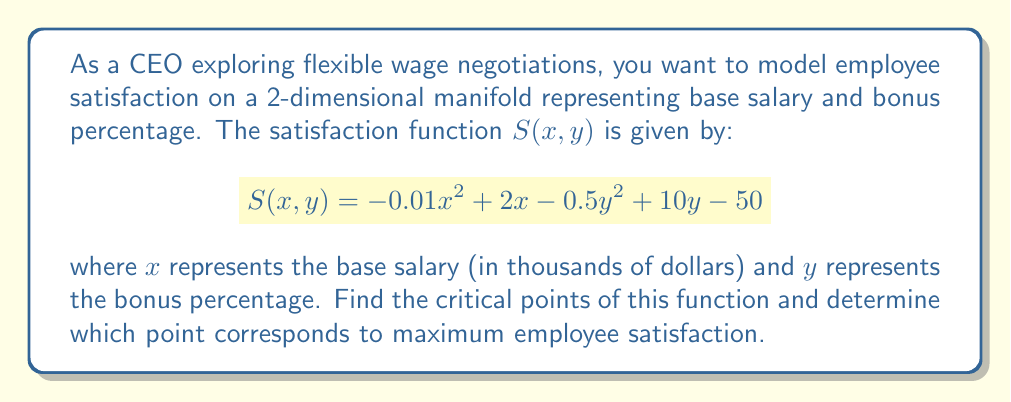Solve this math problem. To find the critical points of the satisfaction function $S(x,y)$, we need to follow these steps:

1. Calculate the partial derivatives of $S$ with respect to $x$ and $y$:

   $$\frac{\partial S}{\partial x} = -0.02x + 2$$
   $$\frac{\partial S}{\partial y} = -y + 10$$

2. Set both partial derivatives to zero and solve the resulting system of equations:

   $$-0.02x + 2 = 0$$
   $$-y + 10 = 0$$

3. Solve for $x$ and $y$:

   $$x = \frac{2}{0.02} = 100$$
   $$y = 10$$

4. The critical point is $(100, 10)$, which represents a base salary of $100,000 and a bonus percentage of 10%.

5. To determine if this critical point is a maximum, we need to calculate the second partial derivatives:

   $$\frac{\partial^2 S}{\partial x^2} = -0.02$$
   $$\frac{\partial^2 S}{\partial y^2} = -1$$
   $$\frac{\partial^2 S}{\partial x\partial y} = \frac{\partial^2 S}{\partial y\partial x} = 0$$

6. The Hessian matrix at the critical point is:

   $$H = \begin{bmatrix} 
   -0.02 & 0 \\
   0 & -1
   \end{bmatrix}$$

7. Since both eigenvalues of the Hessian are negative ($-0.02$ and $-1$), the critical point is a local maximum.

8. Calculate the maximum satisfaction value:

   $$S(100, 10) = -0.01(100)^2 + 2(100) - 0.5(10)^2 + 10(10) - 50 = 125$$

Therefore, the critical point $(100, 10)$ corresponds to the maximum employee satisfaction.
Answer: The critical point is $(100, 10)$, representing a base salary of $100,000 and a bonus percentage of 10%. This point corresponds to the maximum employee satisfaction with a value of 125. 